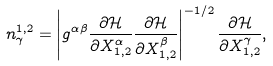Convert formula to latex. <formula><loc_0><loc_0><loc_500><loc_500>n _ { \gamma } ^ { 1 , 2 } = \left | g ^ { \alpha \beta } \frac { \partial \mathcal { H } } { \partial X ^ { \alpha } _ { 1 , 2 } } \frac { \partial \mathcal { H } } { \partial X ^ { \beta } _ { 1 , 2 } } \right | ^ { - 1 / 2 } \frac { \partial \mathcal { H } } { \partial X ^ { \gamma } _ { 1 , 2 } } ,</formula> 